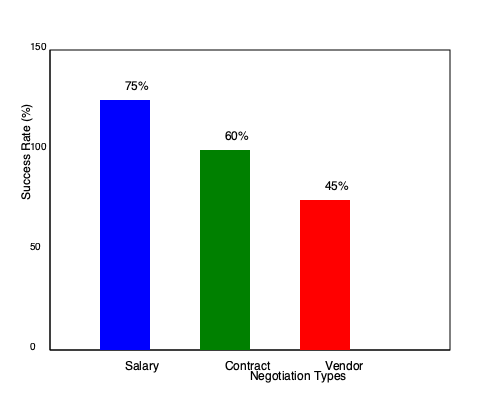Based on the bar graph showing negotiation success rates, which type of negotiation has the highest success rate, and what is the difference in percentage points between the highest and lowest success rates? To answer this question, we need to follow these steps:

1. Identify the success rates for each negotiation type:
   - Salary negotiations: 75%
   - Contract negotiations: 60%
   - Vendor negotiations: 45%

2. Determine which type has the highest success rate:
   Salary negotiations have the highest success rate at 75%.

3. Identify the lowest success rate:
   Vendor negotiations have the lowest success rate at 45%.

4. Calculate the difference between the highest and lowest success rates:
   $75\% - 45\% = 30$ percentage points

Therefore, salary negotiations have the highest success rate, and the difference between the highest (salary) and lowest (vendor) success rates is 30 percentage points.
Answer: Salary; 30 percentage points 